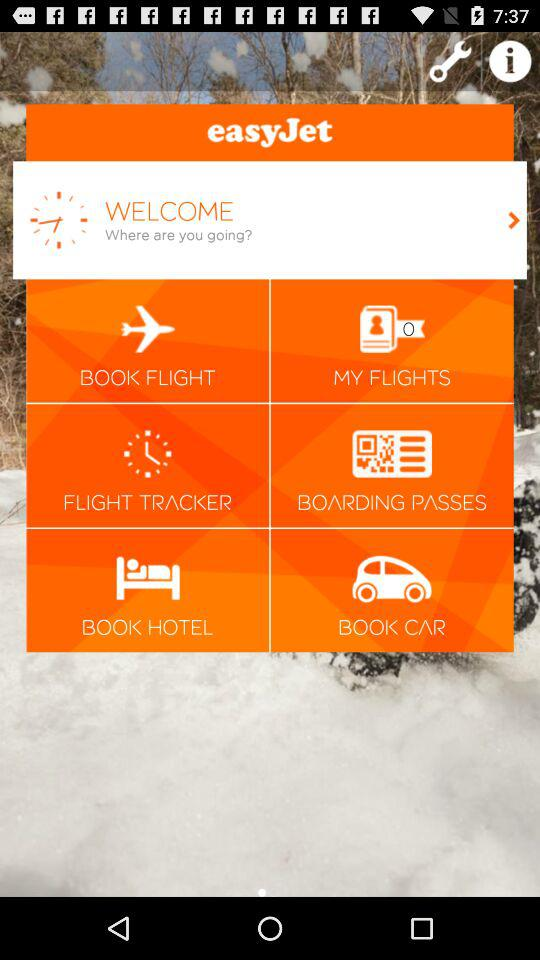What is the app name? The app name is "easyJet". 